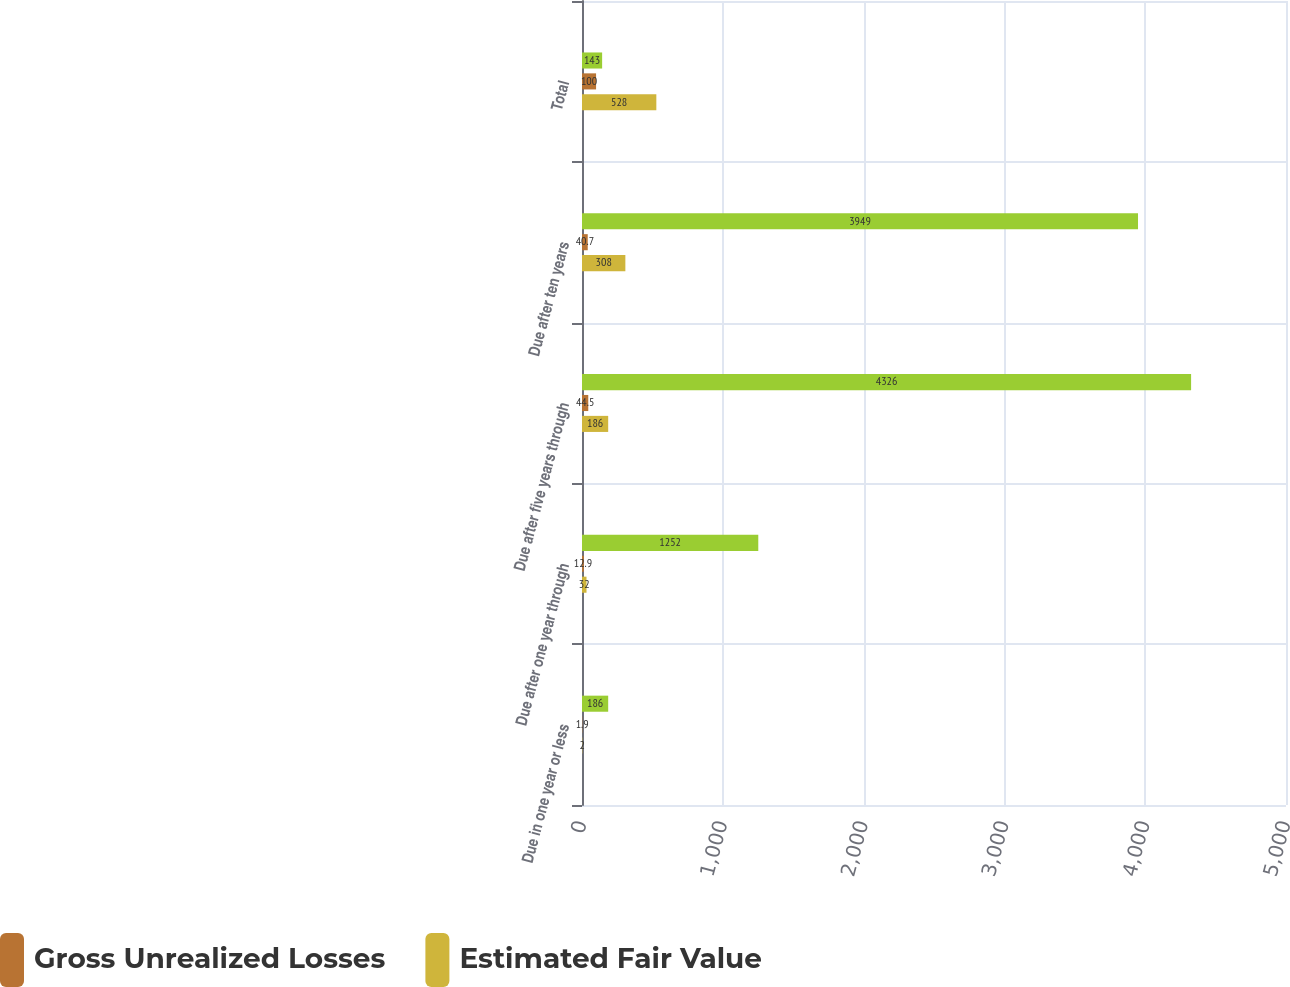Convert chart to OTSL. <chart><loc_0><loc_0><loc_500><loc_500><stacked_bar_chart><ecel><fcel>Due in one year or less<fcel>Due after one year through<fcel>Due after five years through<fcel>Due after ten years<fcel>Total<nl><fcel>nan<fcel>186<fcel>1252<fcel>4326<fcel>3949<fcel>143<nl><fcel>Gross Unrealized Losses<fcel>1.9<fcel>12.9<fcel>44.5<fcel>40.7<fcel>100<nl><fcel>Estimated Fair Value<fcel>2<fcel>32<fcel>186<fcel>308<fcel>528<nl></chart> 